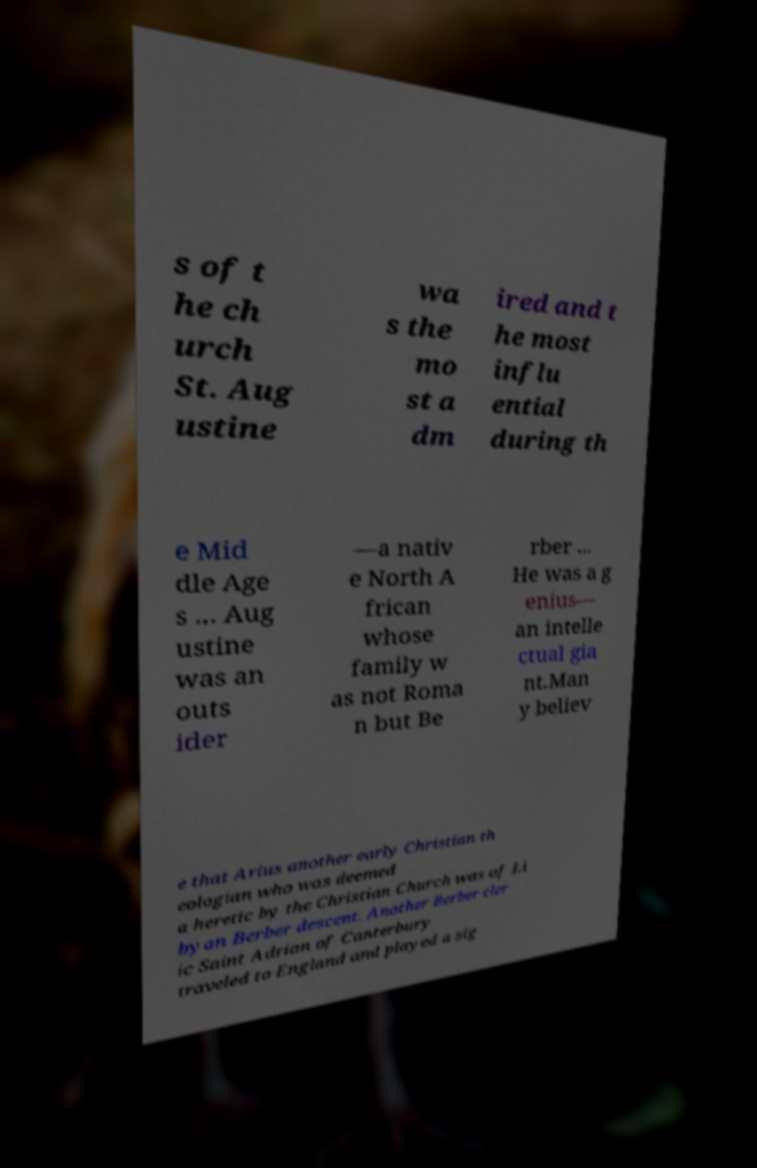Could you assist in decoding the text presented in this image and type it out clearly? s of t he ch urch St. Aug ustine wa s the mo st a dm ired and t he most influ ential during th e Mid dle Age s ... Aug ustine was an outs ider —a nativ e North A frican whose family w as not Roma n but Be rber ... He was a g enius— an intelle ctual gia nt.Man y believ e that Arius another early Christian th eologian who was deemed a heretic by the Christian Church was of Li byan Berber descent. Another Berber cler ic Saint Adrian of Canterbury traveled to England and played a sig 